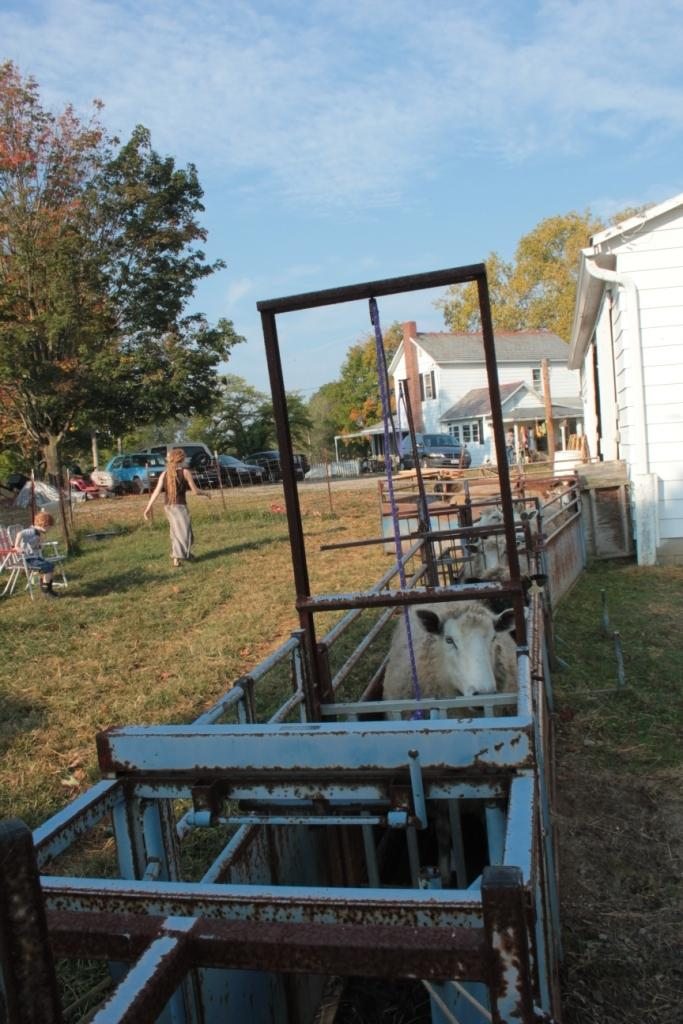What is the metal object containing in the image? There are animals in a metal object in the image. What can be seen in the background of the image? There are houses, cars, trees, and grassy land in the background of the image. Are there any people visible in the image? Yes, there is a woman and a boy in the background of the image. What is visible at the top of the image? The sky is visible at the top of the image. Can you tell me how many times the boy sneezes in the image? There is no indication of the boy sneezing in the image; he is simply standing in the background. What type of pie is being served to the animals in the metal object? There is no pie present in the image; the animals are contained within a metal object. 